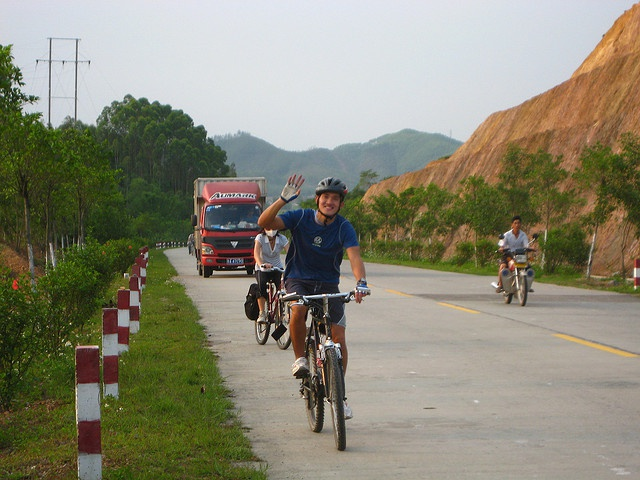Describe the objects in this image and their specific colors. I can see people in lightgray, black, maroon, navy, and brown tones, truck in lightgray, black, brown, gray, and maroon tones, bicycle in lightgray, black, gray, and darkgray tones, people in lightgray, gray, black, and darkgray tones, and bicycle in lightgray, black, gray, darkgray, and maroon tones in this image. 